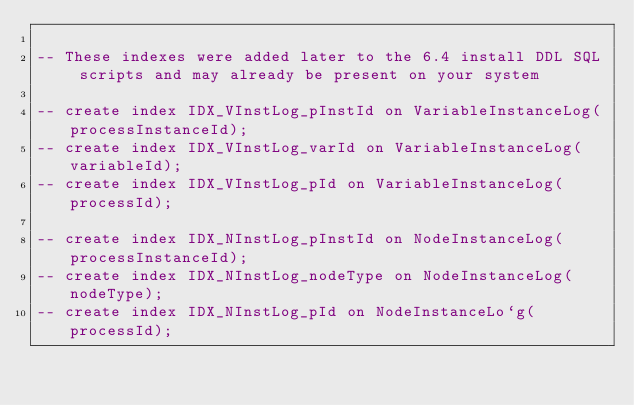Convert code to text. <code><loc_0><loc_0><loc_500><loc_500><_SQL_>
-- These indexes were added later to the 6.4 install DDL SQL scripts and may already be present on your system

-- create index IDX_VInstLog_pInstId on VariableInstanceLog(processInstanceId);
-- create index IDX_VInstLog_varId on VariableInstanceLog(variableId);
-- create index IDX_VInstLog_pId on VariableInstanceLog(processId);

-- create index IDX_NInstLog_pInstId on NodeInstanceLog(processInstanceId);
-- create index IDX_NInstLog_nodeType on NodeInstanceLog(nodeType);
-- create index IDX_NInstLog_pId on NodeInstanceLo`g(processId);
</code> 